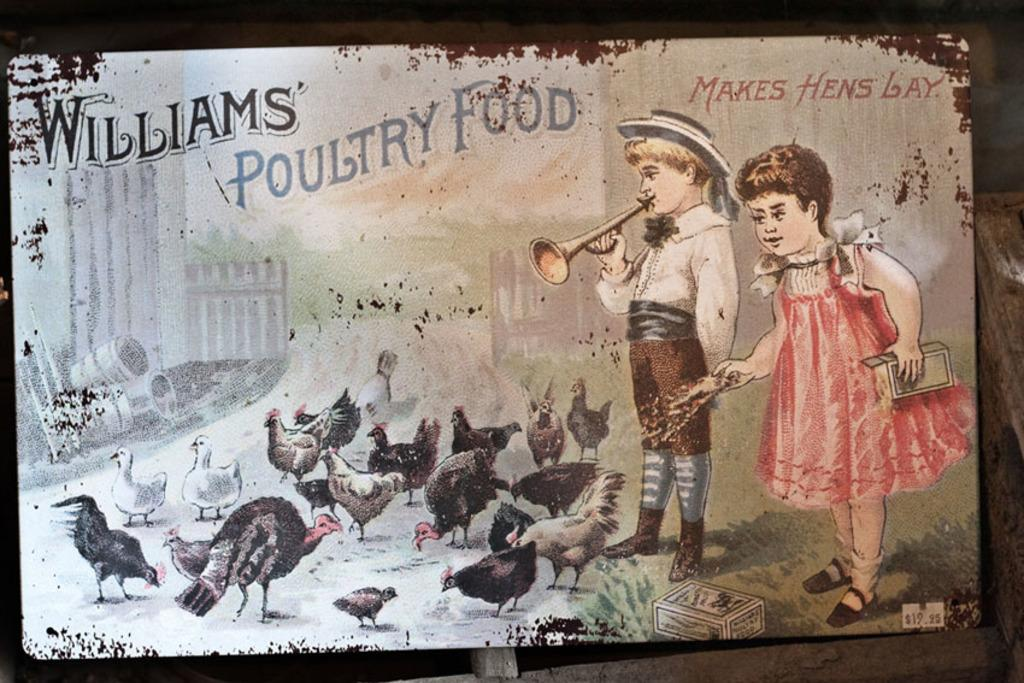What is the main object in the image? There is a board in the image. What can be seen on the board? The board has some painting on it. How many hats are depicted in the painting on the board? There is no mention of hats in the image or the painting on the board, so it is impossible to determine the amount. 